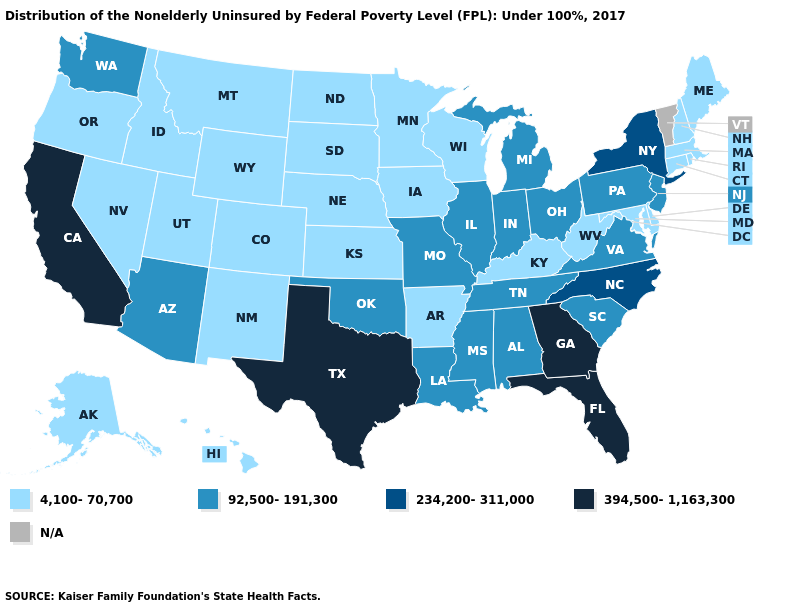Is the legend a continuous bar?
Write a very short answer. No. What is the value of Iowa?
Answer briefly. 4,100-70,700. Which states have the lowest value in the USA?
Give a very brief answer. Alaska, Arkansas, Colorado, Connecticut, Delaware, Hawaii, Idaho, Iowa, Kansas, Kentucky, Maine, Maryland, Massachusetts, Minnesota, Montana, Nebraska, Nevada, New Hampshire, New Mexico, North Dakota, Oregon, Rhode Island, South Dakota, Utah, West Virginia, Wisconsin, Wyoming. Name the states that have a value in the range N/A?
Give a very brief answer. Vermont. Name the states that have a value in the range 92,500-191,300?
Write a very short answer. Alabama, Arizona, Illinois, Indiana, Louisiana, Michigan, Mississippi, Missouri, New Jersey, Ohio, Oklahoma, Pennsylvania, South Carolina, Tennessee, Virginia, Washington. Name the states that have a value in the range 394,500-1,163,300?
Short answer required. California, Florida, Georgia, Texas. Name the states that have a value in the range 394,500-1,163,300?
Write a very short answer. California, Florida, Georgia, Texas. Name the states that have a value in the range 394,500-1,163,300?
Give a very brief answer. California, Florida, Georgia, Texas. Name the states that have a value in the range 92,500-191,300?
Quick response, please. Alabama, Arizona, Illinois, Indiana, Louisiana, Michigan, Mississippi, Missouri, New Jersey, Ohio, Oklahoma, Pennsylvania, South Carolina, Tennessee, Virginia, Washington. Does California have the highest value in the USA?
Short answer required. Yes. What is the value of Maryland?
Give a very brief answer. 4,100-70,700. What is the highest value in the West ?
Short answer required. 394,500-1,163,300. What is the highest value in the West ?
Write a very short answer. 394,500-1,163,300. Among the states that border Arkansas , does Texas have the lowest value?
Quick response, please. No. Name the states that have a value in the range N/A?
Short answer required. Vermont. 